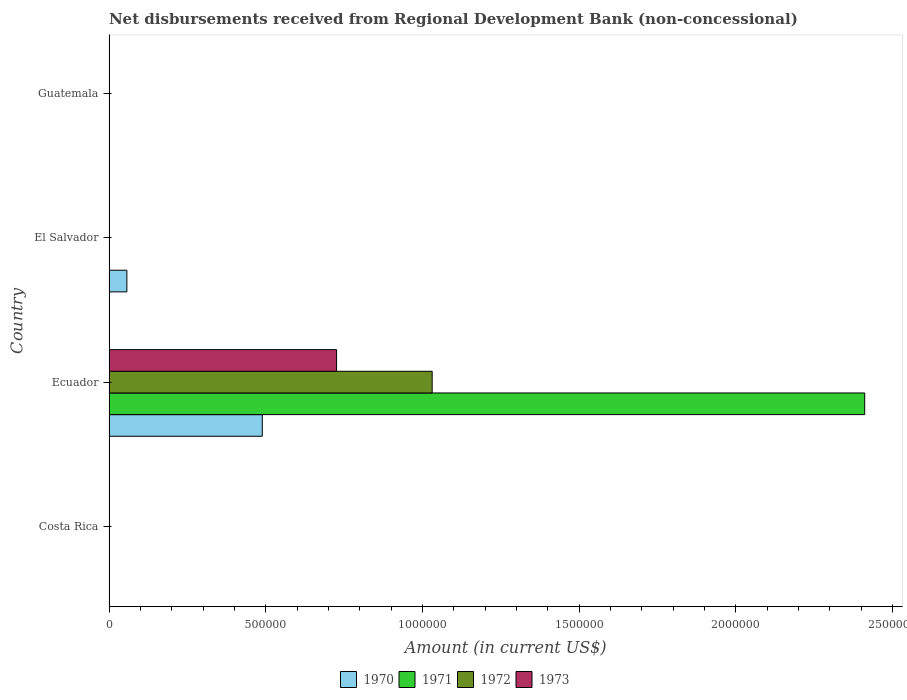How many different coloured bars are there?
Provide a short and direct response. 4. How many bars are there on the 3rd tick from the top?
Make the answer very short. 4. How many bars are there on the 2nd tick from the bottom?
Offer a terse response. 4. What is the label of the 4th group of bars from the top?
Provide a short and direct response. Costa Rica. In how many cases, is the number of bars for a given country not equal to the number of legend labels?
Your answer should be compact. 3. What is the amount of disbursements received from Regional Development Bank in 1973 in El Salvador?
Your answer should be very brief. 0. Across all countries, what is the maximum amount of disbursements received from Regional Development Bank in 1973?
Give a very brief answer. 7.26e+05. Across all countries, what is the minimum amount of disbursements received from Regional Development Bank in 1971?
Offer a terse response. 0. In which country was the amount of disbursements received from Regional Development Bank in 1972 maximum?
Provide a succinct answer. Ecuador. What is the total amount of disbursements received from Regional Development Bank in 1971 in the graph?
Keep it short and to the point. 2.41e+06. What is the difference between the amount of disbursements received from Regional Development Bank in 1970 in Ecuador and that in El Salvador?
Keep it short and to the point. 4.32e+05. What is the difference between the amount of disbursements received from Regional Development Bank in 1971 in El Salvador and the amount of disbursements received from Regional Development Bank in 1970 in Ecuador?
Your response must be concise. -4.89e+05. What is the average amount of disbursements received from Regional Development Bank in 1972 per country?
Offer a terse response. 2.58e+05. What is the difference between the amount of disbursements received from Regional Development Bank in 1970 and amount of disbursements received from Regional Development Bank in 1972 in Ecuador?
Your response must be concise. -5.42e+05. What is the difference between the highest and the lowest amount of disbursements received from Regional Development Bank in 1972?
Provide a succinct answer. 1.03e+06. Is it the case that in every country, the sum of the amount of disbursements received from Regional Development Bank in 1971 and amount of disbursements received from Regional Development Bank in 1970 is greater than the amount of disbursements received from Regional Development Bank in 1972?
Provide a succinct answer. No. Are all the bars in the graph horizontal?
Offer a terse response. Yes. What is the difference between two consecutive major ticks on the X-axis?
Your response must be concise. 5.00e+05. Does the graph contain any zero values?
Your answer should be very brief. Yes. Where does the legend appear in the graph?
Offer a terse response. Bottom center. How many legend labels are there?
Keep it short and to the point. 4. How are the legend labels stacked?
Offer a very short reply. Horizontal. What is the title of the graph?
Offer a terse response. Net disbursements received from Regional Development Bank (non-concessional). What is the label or title of the X-axis?
Offer a terse response. Amount (in current US$). What is the Amount (in current US$) of 1970 in Ecuador?
Provide a short and direct response. 4.89e+05. What is the Amount (in current US$) of 1971 in Ecuador?
Offer a very short reply. 2.41e+06. What is the Amount (in current US$) of 1972 in Ecuador?
Offer a very short reply. 1.03e+06. What is the Amount (in current US$) of 1973 in Ecuador?
Make the answer very short. 7.26e+05. What is the Amount (in current US$) of 1970 in El Salvador?
Offer a terse response. 5.70e+04. What is the Amount (in current US$) in 1971 in El Salvador?
Offer a very short reply. 0. What is the Amount (in current US$) of 1973 in El Salvador?
Your answer should be very brief. 0. What is the Amount (in current US$) of 1970 in Guatemala?
Offer a terse response. 0. What is the Amount (in current US$) of 1971 in Guatemala?
Ensure brevity in your answer.  0. What is the Amount (in current US$) in 1973 in Guatemala?
Ensure brevity in your answer.  0. Across all countries, what is the maximum Amount (in current US$) in 1970?
Keep it short and to the point. 4.89e+05. Across all countries, what is the maximum Amount (in current US$) in 1971?
Make the answer very short. 2.41e+06. Across all countries, what is the maximum Amount (in current US$) of 1972?
Your answer should be compact. 1.03e+06. Across all countries, what is the maximum Amount (in current US$) of 1973?
Your response must be concise. 7.26e+05. Across all countries, what is the minimum Amount (in current US$) in 1970?
Offer a very short reply. 0. Across all countries, what is the minimum Amount (in current US$) of 1971?
Provide a succinct answer. 0. Across all countries, what is the minimum Amount (in current US$) of 1972?
Your response must be concise. 0. What is the total Amount (in current US$) of 1970 in the graph?
Keep it short and to the point. 5.46e+05. What is the total Amount (in current US$) of 1971 in the graph?
Give a very brief answer. 2.41e+06. What is the total Amount (in current US$) in 1972 in the graph?
Offer a terse response. 1.03e+06. What is the total Amount (in current US$) of 1973 in the graph?
Provide a short and direct response. 7.26e+05. What is the difference between the Amount (in current US$) of 1970 in Ecuador and that in El Salvador?
Keep it short and to the point. 4.32e+05. What is the average Amount (in current US$) of 1970 per country?
Ensure brevity in your answer.  1.36e+05. What is the average Amount (in current US$) of 1971 per country?
Offer a terse response. 6.03e+05. What is the average Amount (in current US$) of 1972 per country?
Provide a succinct answer. 2.58e+05. What is the average Amount (in current US$) of 1973 per country?
Your answer should be very brief. 1.82e+05. What is the difference between the Amount (in current US$) in 1970 and Amount (in current US$) in 1971 in Ecuador?
Keep it short and to the point. -1.92e+06. What is the difference between the Amount (in current US$) in 1970 and Amount (in current US$) in 1972 in Ecuador?
Give a very brief answer. -5.42e+05. What is the difference between the Amount (in current US$) in 1970 and Amount (in current US$) in 1973 in Ecuador?
Your response must be concise. -2.37e+05. What is the difference between the Amount (in current US$) of 1971 and Amount (in current US$) of 1972 in Ecuador?
Your answer should be very brief. 1.38e+06. What is the difference between the Amount (in current US$) in 1971 and Amount (in current US$) in 1973 in Ecuador?
Provide a short and direct response. 1.68e+06. What is the difference between the Amount (in current US$) of 1972 and Amount (in current US$) of 1973 in Ecuador?
Make the answer very short. 3.05e+05. What is the ratio of the Amount (in current US$) of 1970 in Ecuador to that in El Salvador?
Your response must be concise. 8.58. What is the difference between the highest and the lowest Amount (in current US$) of 1970?
Provide a short and direct response. 4.89e+05. What is the difference between the highest and the lowest Amount (in current US$) of 1971?
Ensure brevity in your answer.  2.41e+06. What is the difference between the highest and the lowest Amount (in current US$) in 1972?
Your answer should be compact. 1.03e+06. What is the difference between the highest and the lowest Amount (in current US$) in 1973?
Your response must be concise. 7.26e+05. 